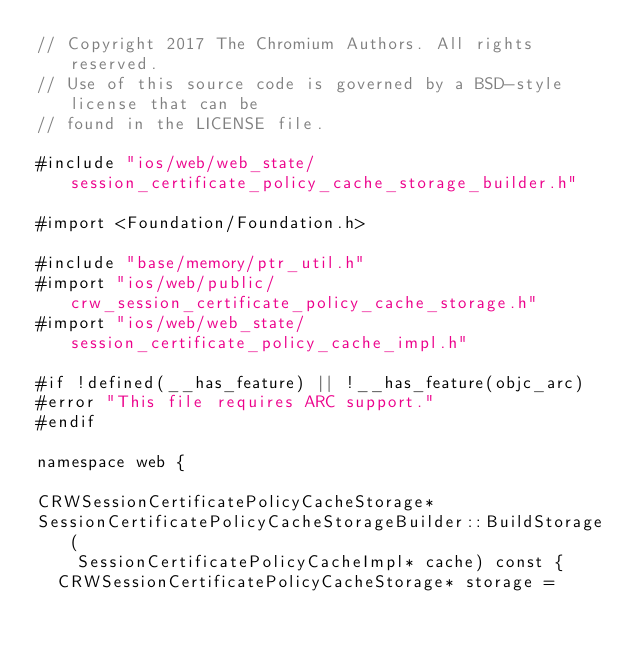<code> <loc_0><loc_0><loc_500><loc_500><_ObjectiveC_>// Copyright 2017 The Chromium Authors. All rights reserved.
// Use of this source code is governed by a BSD-style license that can be
// found in the LICENSE file.

#include "ios/web/web_state/session_certificate_policy_cache_storage_builder.h"

#import <Foundation/Foundation.h>

#include "base/memory/ptr_util.h"
#import "ios/web/public/crw_session_certificate_policy_cache_storage.h"
#import "ios/web/web_state/session_certificate_policy_cache_impl.h"

#if !defined(__has_feature) || !__has_feature(objc_arc)
#error "This file requires ARC support."
#endif

namespace web {

CRWSessionCertificatePolicyCacheStorage*
SessionCertificatePolicyCacheStorageBuilder::BuildStorage(
    SessionCertificatePolicyCacheImpl* cache) const {
  CRWSessionCertificatePolicyCacheStorage* storage =</code> 